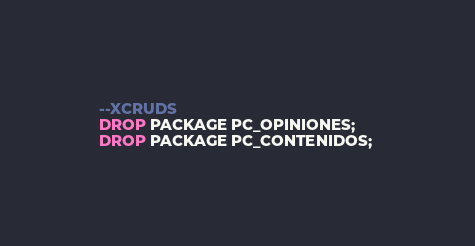<code> <loc_0><loc_0><loc_500><loc_500><_SQL_>--XCRUDS
DROP PACKAGE PC_OPINIONES;
DROP PACKAGE PC_CONTENIDOS; </code> 